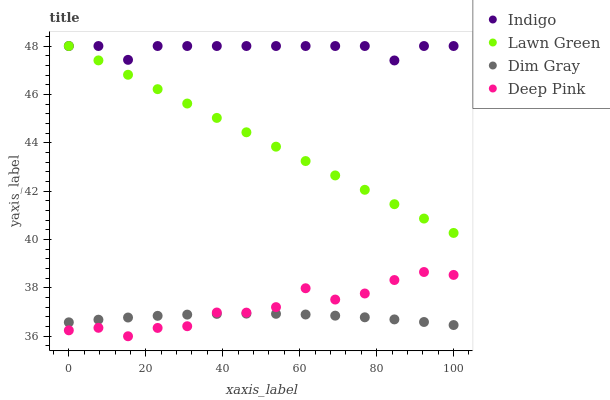Does Dim Gray have the minimum area under the curve?
Answer yes or no. Yes. Does Indigo have the maximum area under the curve?
Answer yes or no. Yes. Does Indigo have the minimum area under the curve?
Answer yes or no. No. Does Dim Gray have the maximum area under the curve?
Answer yes or no. No. Is Lawn Green the smoothest?
Answer yes or no. Yes. Is Deep Pink the roughest?
Answer yes or no. Yes. Is Dim Gray the smoothest?
Answer yes or no. No. Is Dim Gray the roughest?
Answer yes or no. No. Does Deep Pink have the lowest value?
Answer yes or no. Yes. Does Dim Gray have the lowest value?
Answer yes or no. No. Does Indigo have the highest value?
Answer yes or no. Yes. Does Dim Gray have the highest value?
Answer yes or no. No. Is Dim Gray less than Lawn Green?
Answer yes or no. Yes. Is Lawn Green greater than Deep Pink?
Answer yes or no. Yes. Does Indigo intersect Lawn Green?
Answer yes or no. Yes. Is Indigo less than Lawn Green?
Answer yes or no. No. Is Indigo greater than Lawn Green?
Answer yes or no. No. Does Dim Gray intersect Lawn Green?
Answer yes or no. No. 